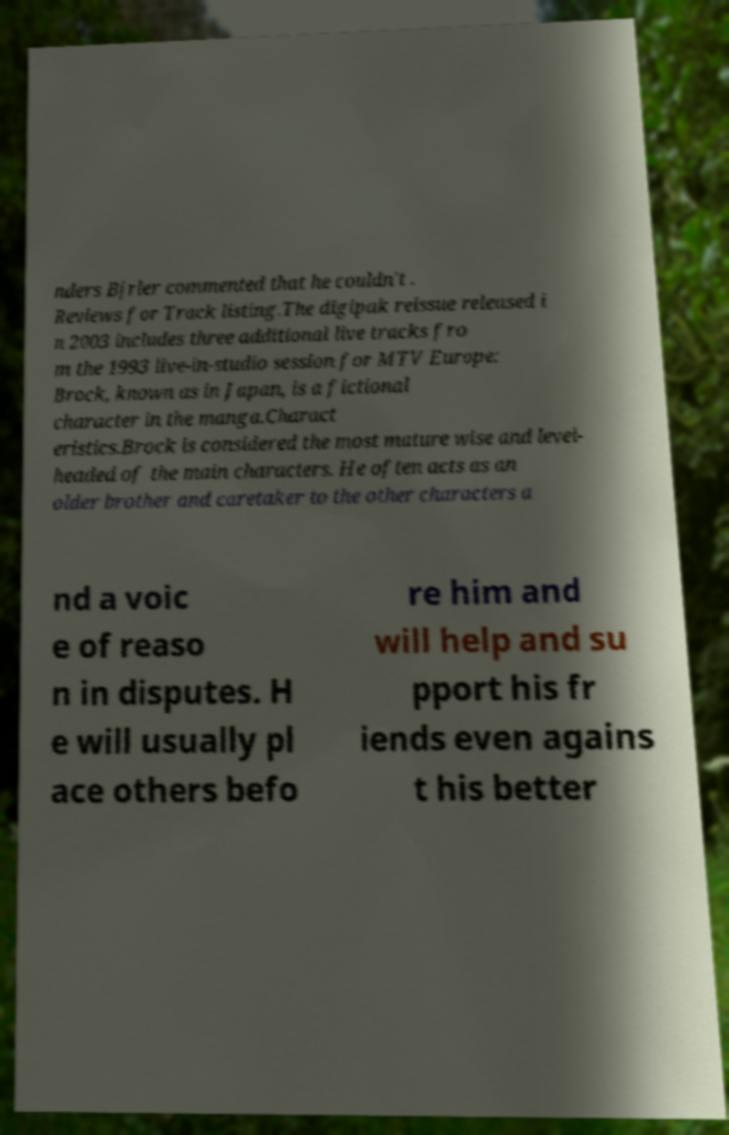There's text embedded in this image that I need extracted. Can you transcribe it verbatim? nders Bjrler commented that he couldn't . Reviews for Track listing.The digipak reissue released i n 2003 includes three additional live tracks fro m the 1993 live-in-studio session for MTV Europe: Brock, known as in Japan, is a fictional character in the manga.Charact eristics.Brock is considered the most mature wise and level- headed of the main characters. He often acts as an older brother and caretaker to the other characters a nd a voic e of reaso n in disputes. H e will usually pl ace others befo re him and will help and su pport his fr iends even agains t his better 